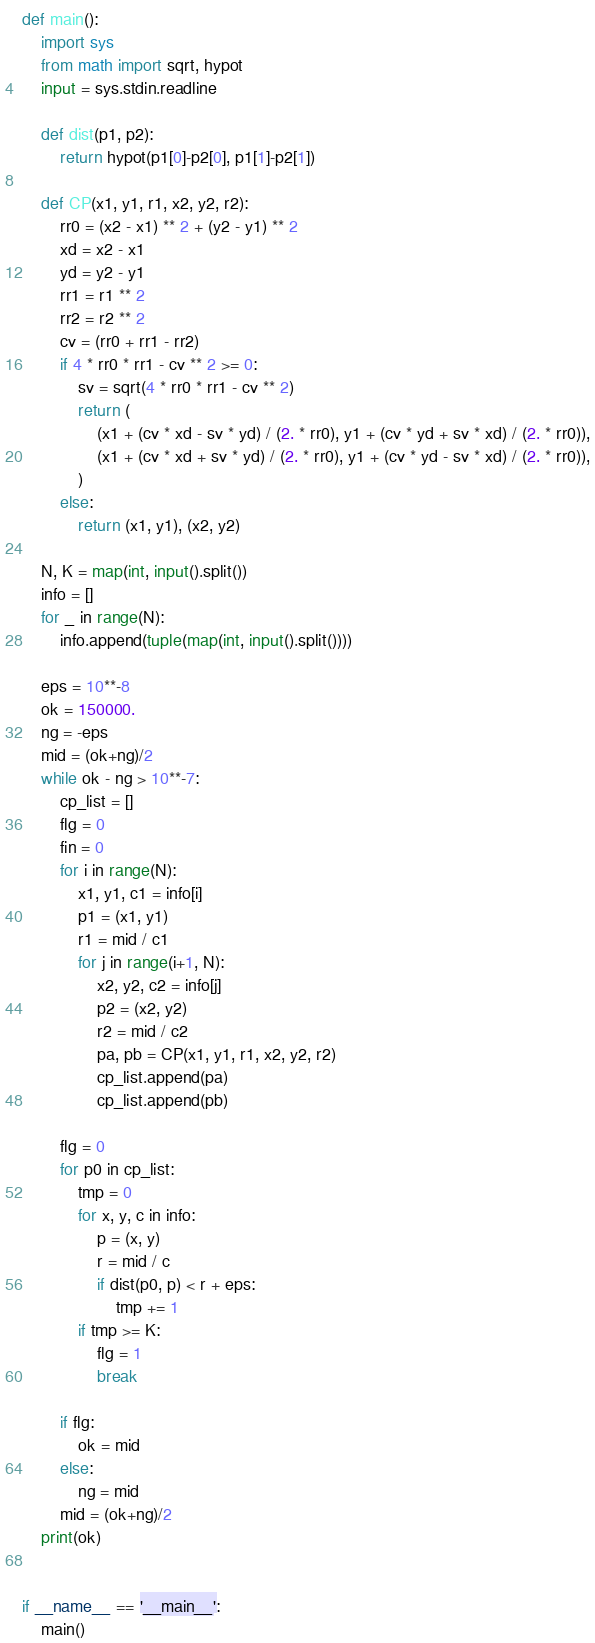Convert code to text. <code><loc_0><loc_0><loc_500><loc_500><_Python_>def main():
    import sys
    from math import sqrt, hypot
    input = sys.stdin.readline

    def dist(p1, p2):
        return hypot(p1[0]-p2[0], p1[1]-p2[1])

    def CP(x1, y1, r1, x2, y2, r2):
        rr0 = (x2 - x1) ** 2 + (y2 - y1) ** 2
        xd = x2 - x1
        yd = y2 - y1
        rr1 = r1 ** 2
        rr2 = r2 ** 2
        cv = (rr0 + rr1 - rr2)
        if 4 * rr0 * rr1 - cv ** 2 >= 0:
            sv = sqrt(4 * rr0 * rr1 - cv ** 2)
            return (
                (x1 + (cv * xd - sv * yd) / (2. * rr0), y1 + (cv * yd + sv * xd) / (2. * rr0)),
                (x1 + (cv * xd + sv * yd) / (2. * rr0), y1 + (cv * yd - sv * xd) / (2. * rr0)),
            )
        else:
            return (x1, y1), (x2, y2)

    N, K = map(int, input().split())
    info = []
    for _ in range(N):
        info.append(tuple(map(int, input().split())))

    eps = 10**-8
    ok = 150000.
    ng = -eps
    mid = (ok+ng)/2
    while ok - ng > 10**-7:
        cp_list = []
        flg = 0
        fin = 0
        for i in range(N):
            x1, y1, c1 = info[i]
            p1 = (x1, y1)
            r1 = mid / c1
            for j in range(i+1, N):
                x2, y2, c2 = info[j]
                p2 = (x2, y2)
                r2 = mid / c2
                pa, pb = CP(x1, y1, r1, x2, y2, r2)
                cp_list.append(pa)
                cp_list.append(pb)

        flg = 0
        for p0 in cp_list:
            tmp = 0
            for x, y, c in info:
                p = (x, y)
                r = mid / c
                if dist(p0, p) < r + eps:
                    tmp += 1
            if tmp >= K:
                flg = 1
                break

        if flg:
            ok = mid
        else:
            ng = mid
        mid = (ok+ng)/2
    print(ok)


if __name__ == '__main__':
    main()
</code> 